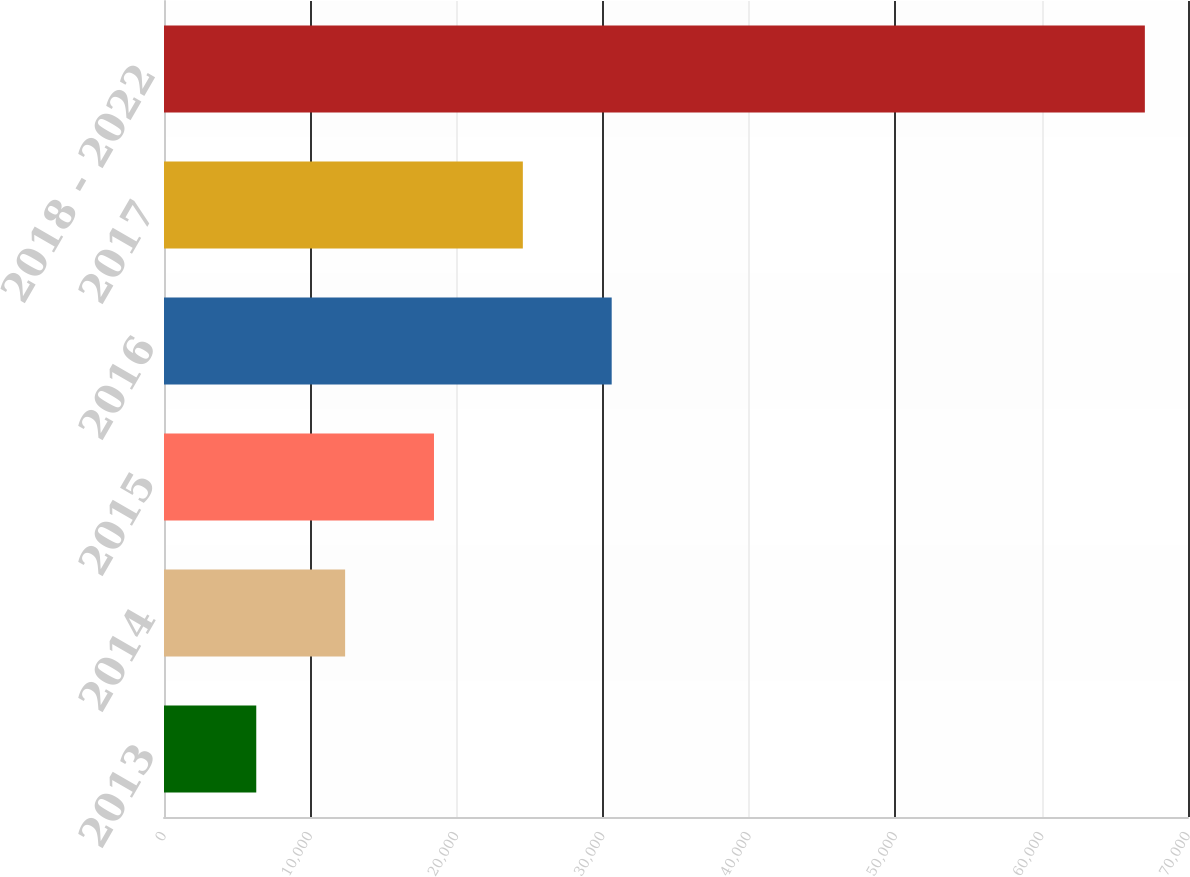<chart> <loc_0><loc_0><loc_500><loc_500><bar_chart><fcel>2013<fcel>2014<fcel>2015<fcel>2016<fcel>2017<fcel>2018 - 2022<nl><fcel>6307<fcel>12381.4<fcel>18455.8<fcel>30604.6<fcel>24530.2<fcel>67051<nl></chart> 